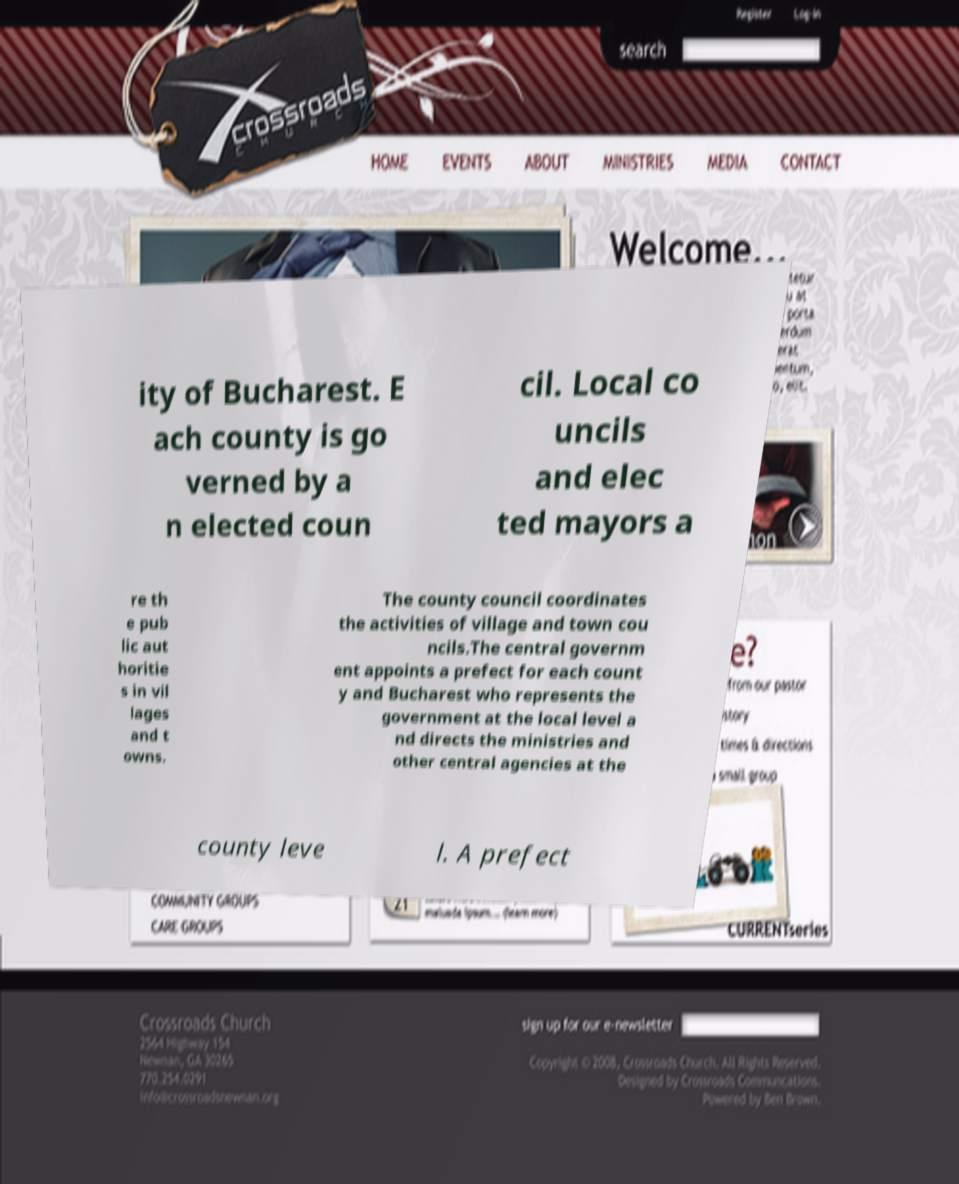What messages or text are displayed in this image? I need them in a readable, typed format. ity of Bucharest. E ach county is go verned by a n elected coun cil. Local co uncils and elec ted mayors a re th e pub lic aut horitie s in vil lages and t owns. The county council coordinates the activities of village and town cou ncils.The central governm ent appoints a prefect for each count y and Bucharest who represents the government at the local level a nd directs the ministries and other central agencies at the county leve l. A prefect 